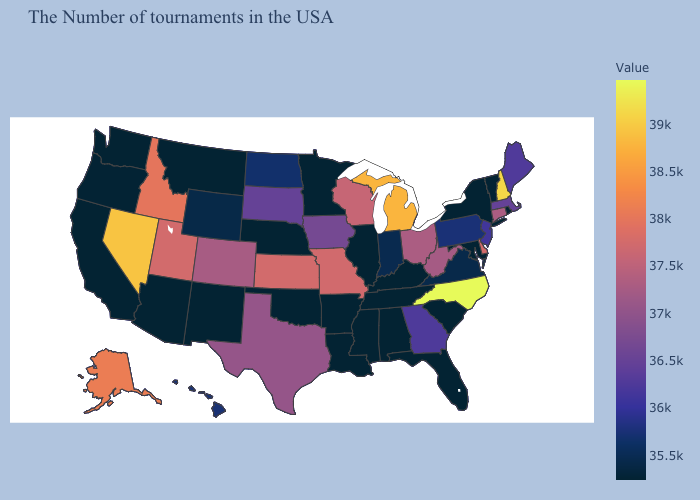Among the states that border Washington , does Idaho have the lowest value?
Answer briefly. No. Does Massachusetts have the lowest value in the Northeast?
Short answer required. No. Does North Carolina have the lowest value in the South?
Be succinct. No. Among the states that border Indiana , which have the lowest value?
Keep it brief. Kentucky, Illinois. Among the states that border Oklahoma , does Missouri have the lowest value?
Concise answer only. No. 